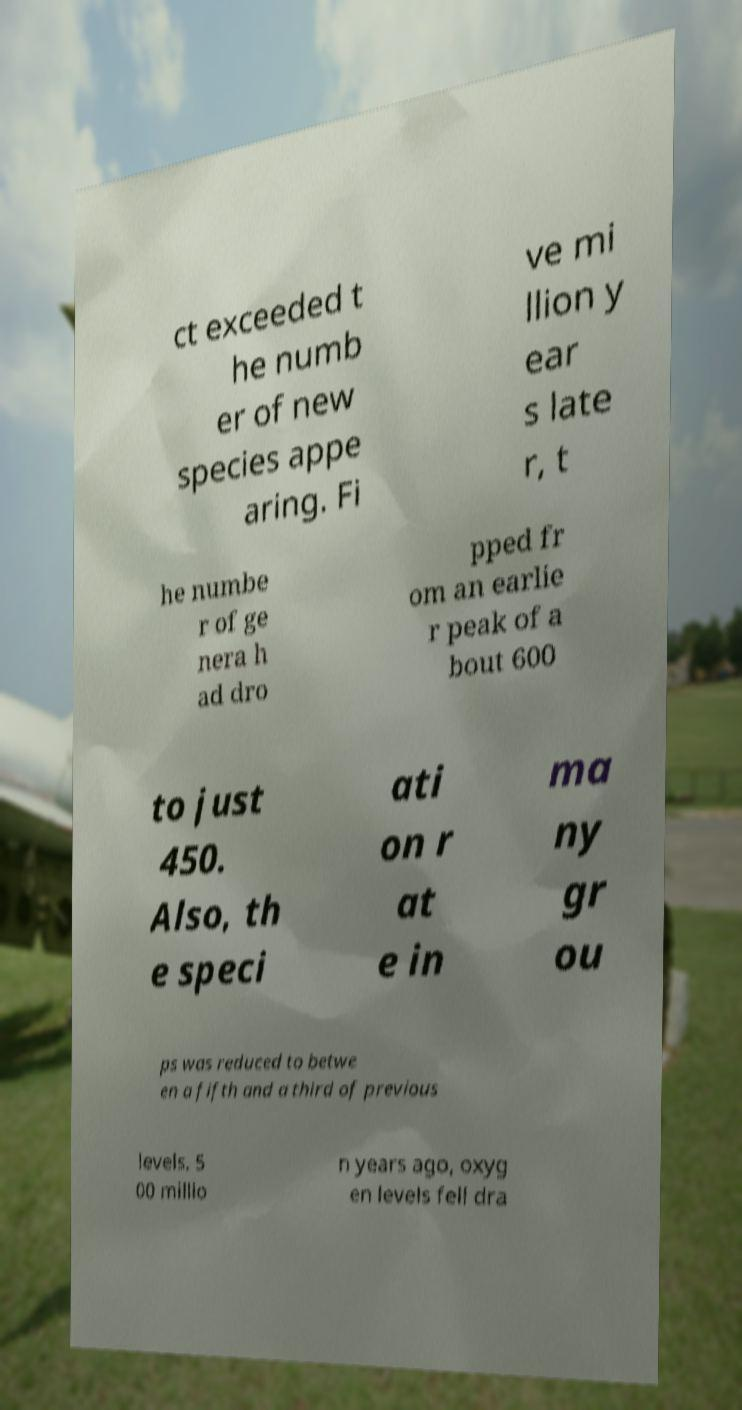Can you read and provide the text displayed in the image?This photo seems to have some interesting text. Can you extract and type it out for me? ct exceeded t he numb er of new species appe aring. Fi ve mi llion y ear s late r, t he numbe r of ge nera h ad dro pped fr om an earlie r peak of a bout 600 to just 450. Also, th e speci ati on r at e in ma ny gr ou ps was reduced to betwe en a fifth and a third of previous levels. 5 00 millio n years ago, oxyg en levels fell dra 